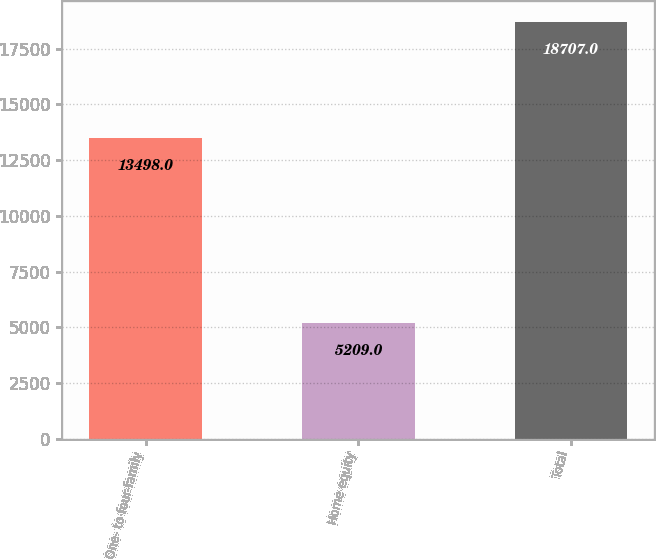<chart> <loc_0><loc_0><loc_500><loc_500><bar_chart><fcel>One- to four-family<fcel>Home equity<fcel>Total<nl><fcel>13498<fcel>5209<fcel>18707<nl></chart> 